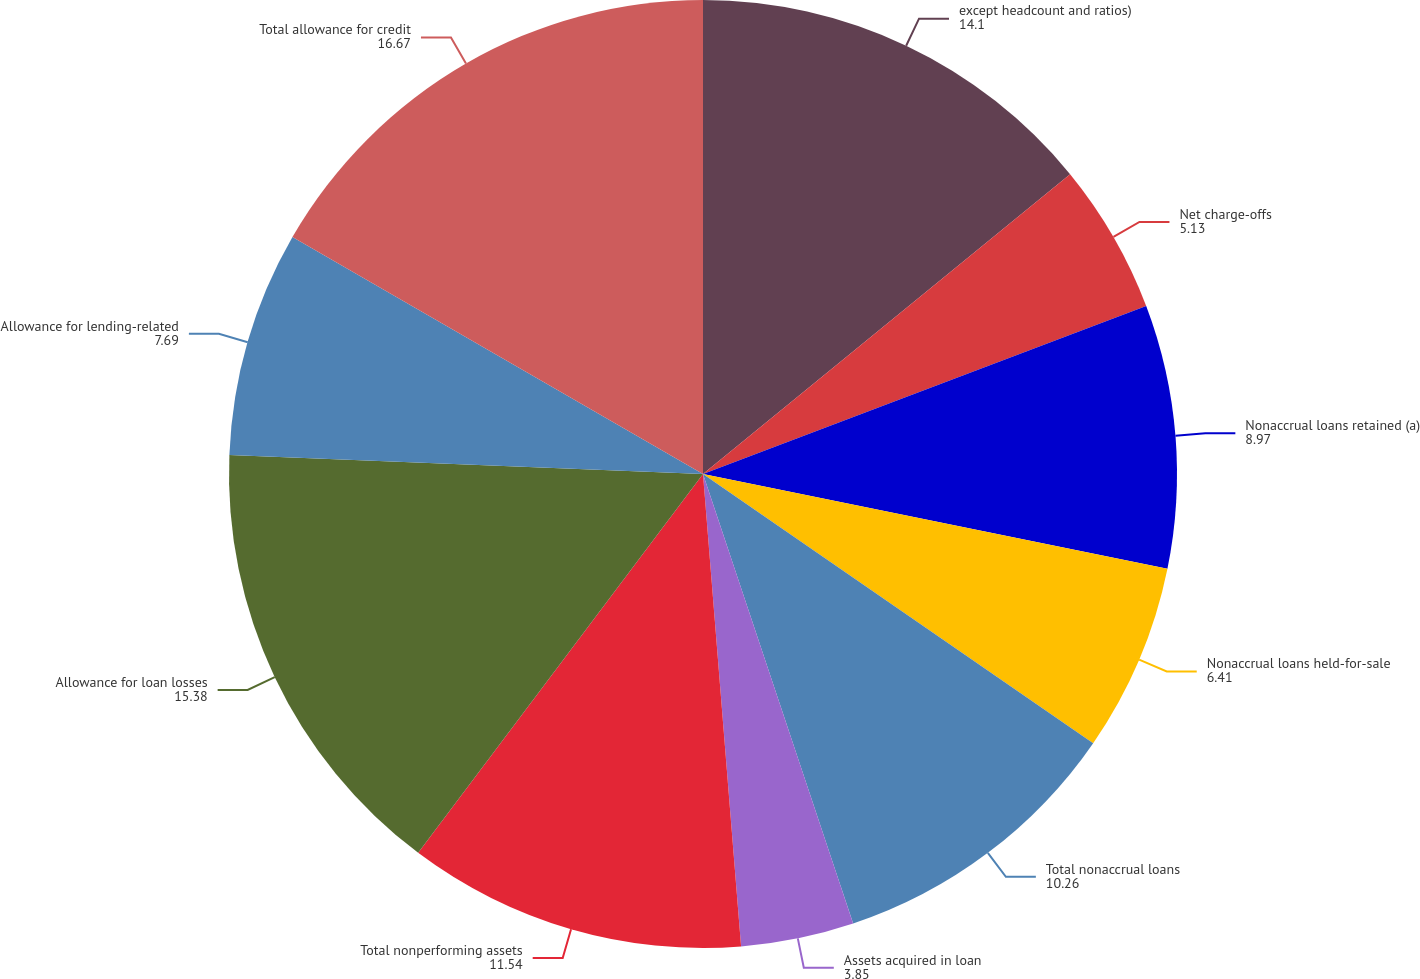Convert chart to OTSL. <chart><loc_0><loc_0><loc_500><loc_500><pie_chart><fcel>except headcount and ratios)<fcel>Net charge-offs<fcel>Nonaccrual loans retained (a)<fcel>Nonaccrual loans held-for-sale<fcel>Total nonaccrual loans<fcel>Assets acquired in loan<fcel>Total nonperforming assets<fcel>Allowance for loan losses<fcel>Allowance for lending-related<fcel>Total allowance for credit<nl><fcel>14.1%<fcel>5.13%<fcel>8.97%<fcel>6.41%<fcel>10.26%<fcel>3.85%<fcel>11.54%<fcel>15.38%<fcel>7.69%<fcel>16.67%<nl></chart> 